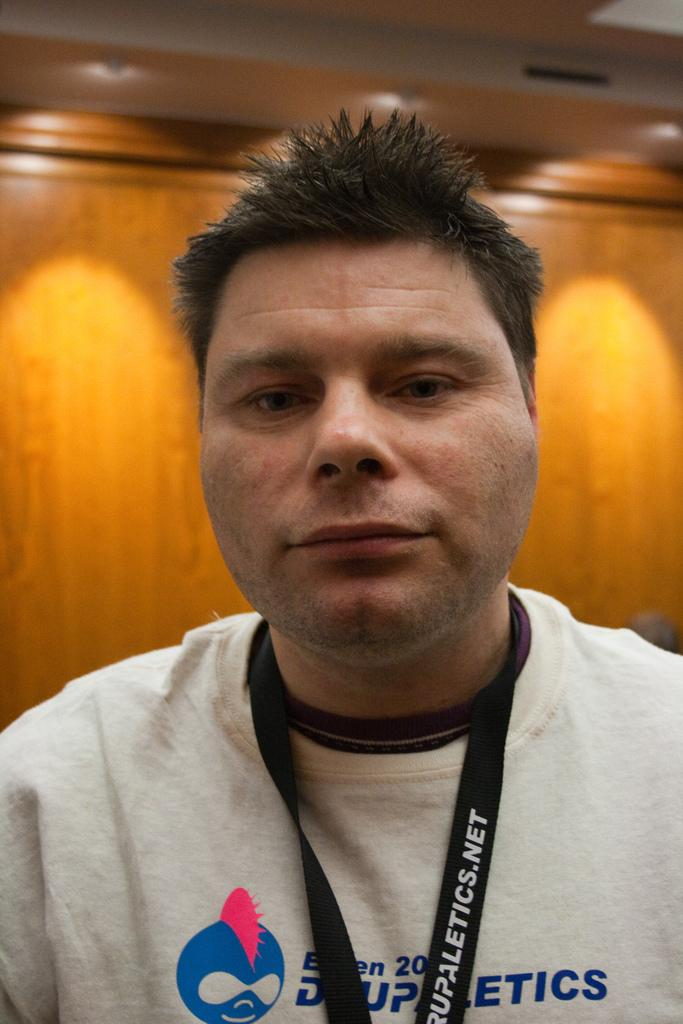<image>
Summarize the visual content of the image. a man that has a website on the item around his neck 